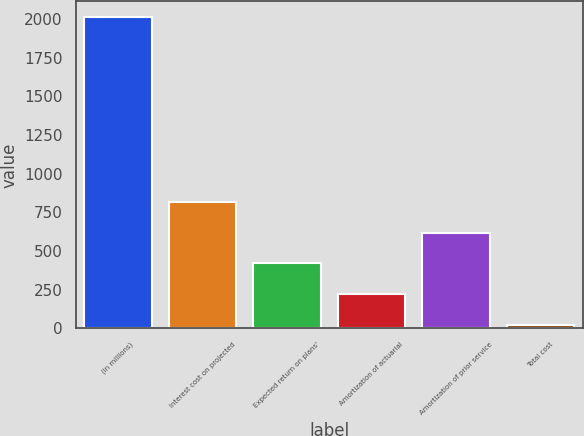Convert chart to OTSL. <chart><loc_0><loc_0><loc_500><loc_500><bar_chart><fcel>(in millions)<fcel>Interest cost on projected<fcel>Expected return on plans'<fcel>Amortization of actuarial<fcel>Amortization of prior service<fcel>Total cost<nl><fcel>2015<fcel>818.6<fcel>419.8<fcel>220.4<fcel>619.2<fcel>21<nl></chart> 